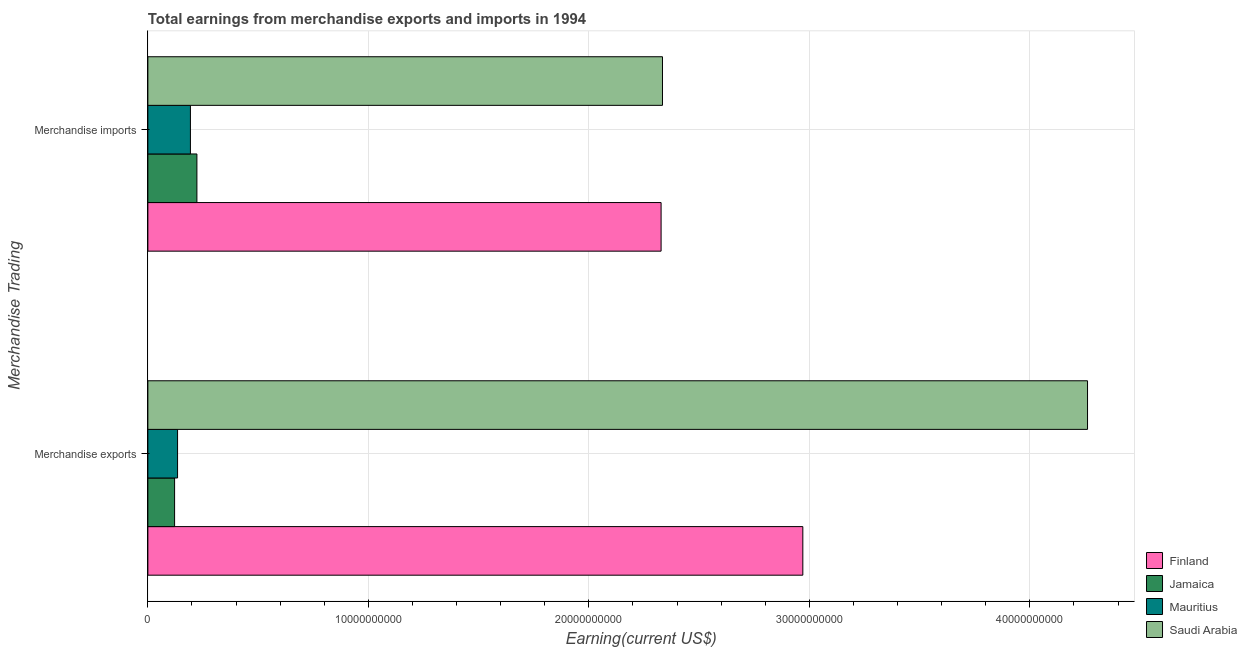How many groups of bars are there?
Ensure brevity in your answer.  2. Are the number of bars per tick equal to the number of legend labels?
Your response must be concise. Yes. Are the number of bars on each tick of the Y-axis equal?
Offer a very short reply. Yes. How many bars are there on the 1st tick from the bottom?
Provide a short and direct response. 4. What is the earnings from merchandise imports in Saudi Arabia?
Keep it short and to the point. 2.33e+1. Across all countries, what is the maximum earnings from merchandise exports?
Provide a short and direct response. 4.26e+1. Across all countries, what is the minimum earnings from merchandise exports?
Make the answer very short. 1.21e+09. In which country was the earnings from merchandise imports maximum?
Provide a succinct answer. Saudi Arabia. In which country was the earnings from merchandise exports minimum?
Your answer should be very brief. Jamaica. What is the total earnings from merchandise imports in the graph?
Provide a succinct answer. 5.08e+1. What is the difference between the earnings from merchandise imports in Finland and that in Saudi Arabia?
Your answer should be very brief. -6.30e+07. What is the difference between the earnings from merchandise exports in Saudi Arabia and the earnings from merchandise imports in Jamaica?
Provide a succinct answer. 4.04e+1. What is the average earnings from merchandise imports per country?
Make the answer very short. 1.27e+1. What is the difference between the earnings from merchandise imports and earnings from merchandise exports in Jamaica?
Give a very brief answer. 1.01e+09. In how many countries, is the earnings from merchandise exports greater than 6000000000 US$?
Offer a terse response. 2. What is the ratio of the earnings from merchandise imports in Finland to that in Saudi Arabia?
Offer a very short reply. 1. Is the earnings from merchandise exports in Jamaica less than that in Mauritius?
Your answer should be compact. Yes. In how many countries, is the earnings from merchandise exports greater than the average earnings from merchandise exports taken over all countries?
Your answer should be very brief. 2. What does the 2nd bar from the top in Merchandise exports represents?
Give a very brief answer. Mauritius. What does the 3rd bar from the bottom in Merchandise exports represents?
Offer a very short reply. Mauritius. Are all the bars in the graph horizontal?
Your answer should be compact. Yes. How many countries are there in the graph?
Your answer should be compact. 4. What is the difference between two consecutive major ticks on the X-axis?
Provide a short and direct response. 1.00e+1. Does the graph contain grids?
Provide a succinct answer. Yes. Where does the legend appear in the graph?
Provide a short and direct response. Bottom right. How are the legend labels stacked?
Keep it short and to the point. Vertical. What is the title of the graph?
Your answer should be very brief. Total earnings from merchandise exports and imports in 1994. What is the label or title of the X-axis?
Give a very brief answer. Earning(current US$). What is the label or title of the Y-axis?
Ensure brevity in your answer.  Merchandise Trading. What is the Earning(current US$) in Finland in Merchandise exports?
Keep it short and to the point. 2.97e+1. What is the Earning(current US$) of Jamaica in Merchandise exports?
Make the answer very short. 1.21e+09. What is the Earning(current US$) in Mauritius in Merchandise exports?
Offer a very short reply. 1.35e+09. What is the Earning(current US$) of Saudi Arabia in Merchandise exports?
Give a very brief answer. 4.26e+1. What is the Earning(current US$) of Finland in Merchandise imports?
Offer a very short reply. 2.33e+1. What is the Earning(current US$) of Jamaica in Merchandise imports?
Provide a succinct answer. 2.22e+09. What is the Earning(current US$) of Mauritius in Merchandise imports?
Give a very brief answer. 1.93e+09. What is the Earning(current US$) in Saudi Arabia in Merchandise imports?
Your answer should be compact. 2.33e+1. Across all Merchandise Trading, what is the maximum Earning(current US$) of Finland?
Offer a terse response. 2.97e+1. Across all Merchandise Trading, what is the maximum Earning(current US$) of Jamaica?
Offer a very short reply. 2.22e+09. Across all Merchandise Trading, what is the maximum Earning(current US$) in Mauritius?
Give a very brief answer. 1.93e+09. Across all Merchandise Trading, what is the maximum Earning(current US$) in Saudi Arabia?
Ensure brevity in your answer.  4.26e+1. Across all Merchandise Trading, what is the minimum Earning(current US$) in Finland?
Your answer should be compact. 2.33e+1. Across all Merchandise Trading, what is the minimum Earning(current US$) of Jamaica?
Give a very brief answer. 1.21e+09. Across all Merchandise Trading, what is the minimum Earning(current US$) of Mauritius?
Offer a very short reply. 1.35e+09. Across all Merchandise Trading, what is the minimum Earning(current US$) of Saudi Arabia?
Provide a succinct answer. 2.33e+1. What is the total Earning(current US$) of Finland in the graph?
Your answer should be very brief. 5.30e+1. What is the total Earning(current US$) in Jamaica in the graph?
Offer a terse response. 3.44e+09. What is the total Earning(current US$) in Mauritius in the graph?
Make the answer very short. 3.28e+09. What is the total Earning(current US$) in Saudi Arabia in the graph?
Your answer should be compact. 6.60e+1. What is the difference between the Earning(current US$) in Finland in Merchandise exports and that in Merchandise imports?
Make the answer very short. 6.43e+09. What is the difference between the Earning(current US$) of Jamaica in Merchandise exports and that in Merchandise imports?
Your response must be concise. -1.01e+09. What is the difference between the Earning(current US$) of Mauritius in Merchandise exports and that in Merchandise imports?
Offer a terse response. -5.83e+08. What is the difference between the Earning(current US$) in Saudi Arabia in Merchandise exports and that in Merchandise imports?
Your answer should be compact. 1.93e+1. What is the difference between the Earning(current US$) in Finland in Merchandise exports and the Earning(current US$) in Jamaica in Merchandise imports?
Provide a short and direct response. 2.75e+1. What is the difference between the Earning(current US$) in Finland in Merchandise exports and the Earning(current US$) in Mauritius in Merchandise imports?
Provide a succinct answer. 2.78e+1. What is the difference between the Earning(current US$) of Finland in Merchandise exports and the Earning(current US$) of Saudi Arabia in Merchandise imports?
Ensure brevity in your answer.  6.36e+09. What is the difference between the Earning(current US$) in Jamaica in Merchandise exports and the Earning(current US$) in Mauritius in Merchandise imports?
Offer a very short reply. -7.18e+08. What is the difference between the Earning(current US$) of Jamaica in Merchandise exports and the Earning(current US$) of Saudi Arabia in Merchandise imports?
Your response must be concise. -2.21e+1. What is the difference between the Earning(current US$) in Mauritius in Merchandise exports and the Earning(current US$) in Saudi Arabia in Merchandise imports?
Provide a succinct answer. -2.20e+1. What is the average Earning(current US$) in Finland per Merchandise Trading?
Keep it short and to the point. 2.65e+1. What is the average Earning(current US$) of Jamaica per Merchandise Trading?
Your answer should be very brief. 1.72e+09. What is the average Earning(current US$) in Mauritius per Merchandise Trading?
Your answer should be very brief. 1.64e+09. What is the average Earning(current US$) in Saudi Arabia per Merchandise Trading?
Provide a short and direct response. 3.30e+1. What is the difference between the Earning(current US$) of Finland and Earning(current US$) of Jamaica in Merchandise exports?
Your response must be concise. 2.85e+1. What is the difference between the Earning(current US$) of Finland and Earning(current US$) of Mauritius in Merchandise exports?
Offer a very short reply. 2.84e+1. What is the difference between the Earning(current US$) in Finland and Earning(current US$) in Saudi Arabia in Merchandise exports?
Provide a short and direct response. -1.29e+1. What is the difference between the Earning(current US$) of Jamaica and Earning(current US$) of Mauritius in Merchandise exports?
Ensure brevity in your answer.  -1.35e+08. What is the difference between the Earning(current US$) of Jamaica and Earning(current US$) of Saudi Arabia in Merchandise exports?
Offer a very short reply. -4.14e+1. What is the difference between the Earning(current US$) in Mauritius and Earning(current US$) in Saudi Arabia in Merchandise exports?
Your answer should be compact. -4.13e+1. What is the difference between the Earning(current US$) in Finland and Earning(current US$) in Jamaica in Merchandise imports?
Ensure brevity in your answer.  2.11e+1. What is the difference between the Earning(current US$) of Finland and Earning(current US$) of Mauritius in Merchandise imports?
Offer a very short reply. 2.13e+1. What is the difference between the Earning(current US$) in Finland and Earning(current US$) in Saudi Arabia in Merchandise imports?
Provide a short and direct response. -6.30e+07. What is the difference between the Earning(current US$) in Jamaica and Earning(current US$) in Mauritius in Merchandise imports?
Your answer should be very brief. 2.94e+08. What is the difference between the Earning(current US$) of Jamaica and Earning(current US$) of Saudi Arabia in Merchandise imports?
Your response must be concise. -2.11e+1. What is the difference between the Earning(current US$) in Mauritius and Earning(current US$) in Saudi Arabia in Merchandise imports?
Your answer should be very brief. -2.14e+1. What is the ratio of the Earning(current US$) in Finland in Merchandise exports to that in Merchandise imports?
Offer a very short reply. 1.28. What is the ratio of the Earning(current US$) in Jamaica in Merchandise exports to that in Merchandise imports?
Give a very brief answer. 0.55. What is the ratio of the Earning(current US$) of Mauritius in Merchandise exports to that in Merchandise imports?
Ensure brevity in your answer.  0.7. What is the ratio of the Earning(current US$) of Saudi Arabia in Merchandise exports to that in Merchandise imports?
Provide a short and direct response. 1.83. What is the difference between the highest and the second highest Earning(current US$) in Finland?
Ensure brevity in your answer.  6.43e+09. What is the difference between the highest and the second highest Earning(current US$) in Jamaica?
Your answer should be compact. 1.01e+09. What is the difference between the highest and the second highest Earning(current US$) in Mauritius?
Offer a terse response. 5.83e+08. What is the difference between the highest and the second highest Earning(current US$) of Saudi Arabia?
Your answer should be very brief. 1.93e+1. What is the difference between the highest and the lowest Earning(current US$) in Finland?
Your response must be concise. 6.43e+09. What is the difference between the highest and the lowest Earning(current US$) in Jamaica?
Give a very brief answer. 1.01e+09. What is the difference between the highest and the lowest Earning(current US$) in Mauritius?
Keep it short and to the point. 5.83e+08. What is the difference between the highest and the lowest Earning(current US$) of Saudi Arabia?
Offer a very short reply. 1.93e+1. 